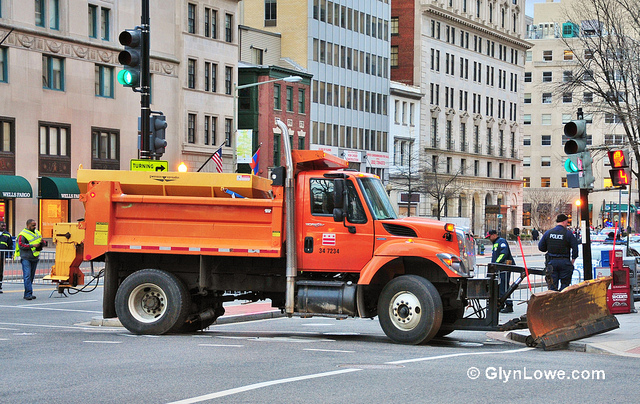Describe the following image. The image prominently features an orange truck, positioned slightly left of center and occupying a considerable portion of the view. The truck is equipped with a plow blade at the front and is likely used for road maintenance. In the backdrop, there are four awnings—two on the far left, one slightly right of center, and the last on the far right. The scene is set in an urban environment with various buildings lining the street. There are four traffic lights visible: one is located high on the left, another is lower and to the right, a third is towards the top right, and the last one is near the center. Additionally, two individuals in high-visibility vests are present in the scene; one is on the far left, appearing to manage the scene, and the other is on the far right, possibly assisting with traffic or road maintenance work. The setting appears to be a well-organized city street with traffic management in progress. 